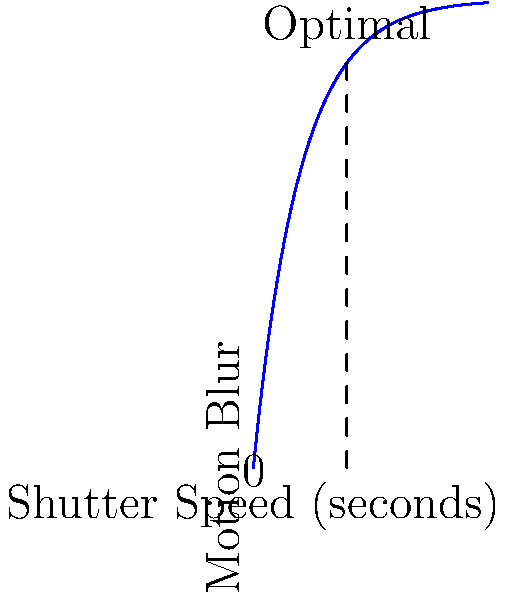As you observe the club member capturing candid moments on a busy street, you notice they're adjusting their camera settings. Based on the graph showing the relationship between shutter speed and motion blur, what is the optimal shutter speed range (in seconds) for capturing a moderate amount of motion blur while still maintaining some sharpness in the moving subjects? To determine the optimal shutter speed range for capturing motion blur in a busy street setting, let's analyze the graph step-by-step:

1. The x-axis represents shutter speed in seconds, while the y-axis represents the amount of motion blur.

2. The curve shows an exponential relationship between shutter speed and motion blur. As shutter speed increases, the amount of motion blur increases but at a decreasing rate.

3. For capturing moderate motion blur while maintaining some sharpness, we want to find the range where the curve starts to level off, indicating a balance between blur and sharpness.

4. Looking at the graph, we can see that the curve begins to level off around the point labeled "Optimal."

5. This point corresponds to a shutter speed of approximately 0.2 seconds on the x-axis.

6. To provide a range, we can consider shutter speeds slightly below and above this point, where the curve is still relatively steep but starting to flatten.

7. A suitable range would be approximately 0.1 to 0.3 seconds, centered around the optimal point of 0.2 seconds.

8. This range allows for some flexibility in capturing different levels of motion blur while still maintaining a degree of sharpness in the moving subjects.

Therefore, the optimal shutter speed range for capturing moderate motion blur in a busy street setting, based on the given graph, is approximately 0.1 to 0.3 seconds.
Answer: 0.1 to 0.3 seconds 